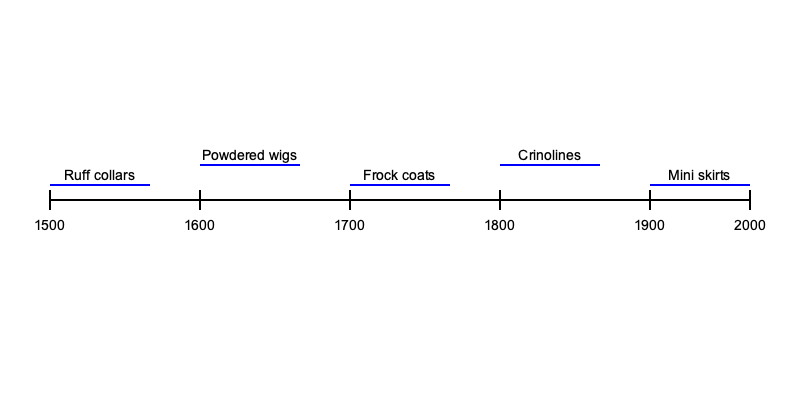Based on the timeline illustration of clothing fashion evolution, which fashion item emerged earliest and was most prevalent during the Renaissance period? To answer this question, we need to analyze the timeline and the fashion items shown:

1. The timeline spans from 1500 to 2000, covering five centuries of fashion history.

2. The fashion items shown are:
   - Ruff collars
   - Powdered wigs
   - Frock coats
   - Crinolines
   - Mini skirts

3. The Renaissance period is generally considered to have occurred from the 14th to the 17th century, with its peak in the 16th century.

4. Looking at the timeline:
   - Ruff collars are shown starting from 1500 and extending to about 1600.
   - Powdered wigs appear from around 1600 to 1700.
   - Frock coats are depicted from 1700 to 1800.
   - Crinolines are shown from 1800 to 1900.
   - Mini skirts appear from 1900 onwards.

5. Among these items, only ruff collars fall within the Renaissance period, specifically the late Renaissance.

6. Ruff collars were indeed a prominent fashion item during the Renaissance, particularly in the late 16th century. They were worn by both men and women of the upper classes and were a symbol of status and wealth.

Therefore, based on the timeline illustration, ruff collars emerged earliest and were most prevalent during the Renaissance period.
Answer: Ruff collars 